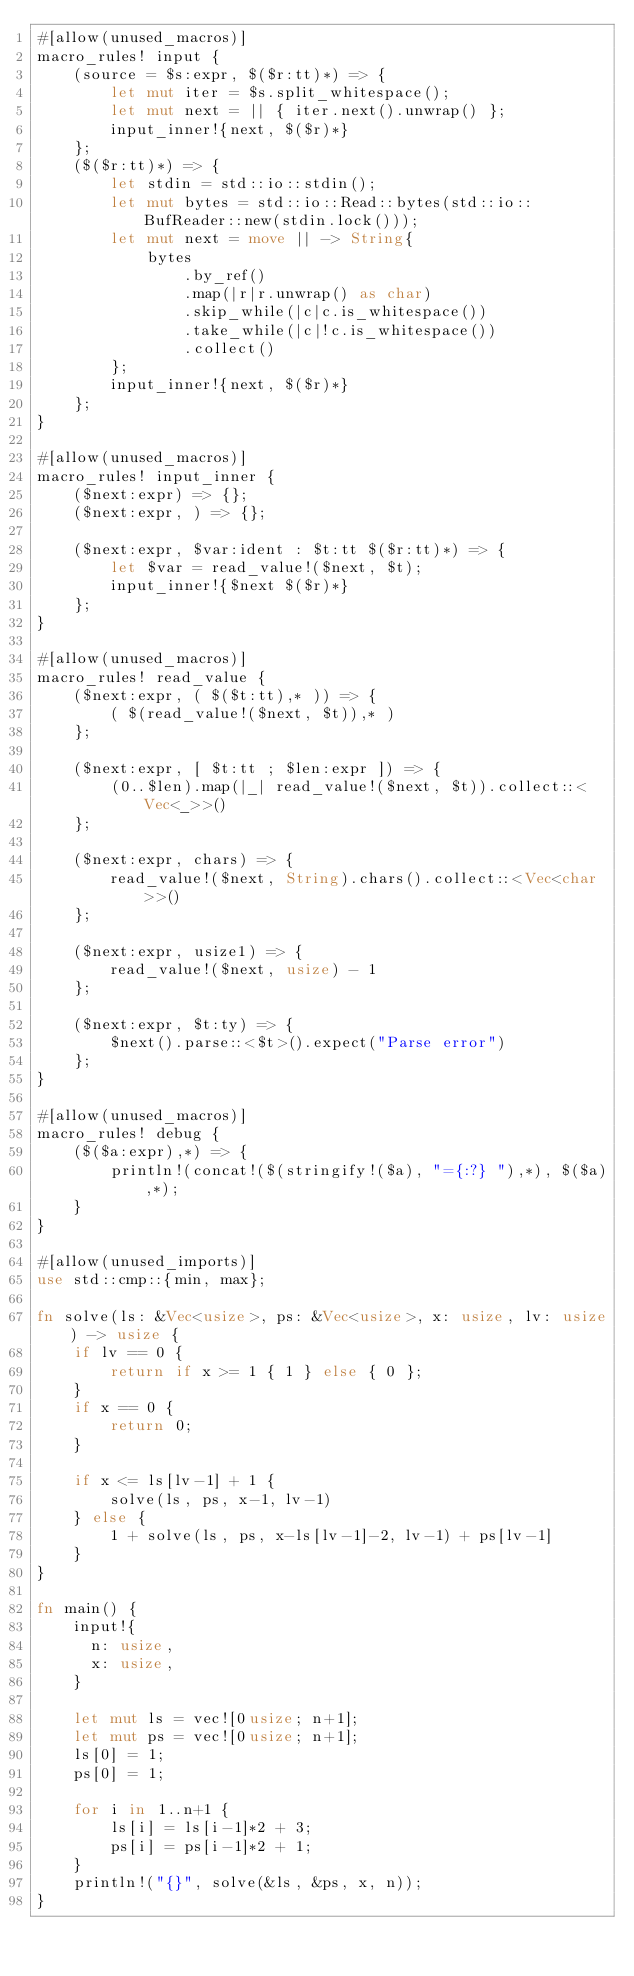Convert code to text. <code><loc_0><loc_0><loc_500><loc_500><_Rust_>#[allow(unused_macros)]
macro_rules! input {
    (source = $s:expr, $($r:tt)*) => {
        let mut iter = $s.split_whitespace();
        let mut next = || { iter.next().unwrap() };
        input_inner!{next, $($r)*}
    };
    ($($r:tt)*) => {
        let stdin = std::io::stdin();
        let mut bytes = std::io::Read::bytes(std::io::BufReader::new(stdin.lock()));
        let mut next = move || -> String{
            bytes
                .by_ref()
                .map(|r|r.unwrap() as char)
                .skip_while(|c|c.is_whitespace())
                .take_while(|c|!c.is_whitespace())
                .collect()
        };
        input_inner!{next, $($r)*}
    };
}

#[allow(unused_macros)]
macro_rules! input_inner {
    ($next:expr) => {};
    ($next:expr, ) => {};

    ($next:expr, $var:ident : $t:tt $($r:tt)*) => {
        let $var = read_value!($next, $t);
        input_inner!{$next $($r)*}
    };
}

#[allow(unused_macros)]
macro_rules! read_value {
    ($next:expr, ( $($t:tt),* )) => {
        ( $(read_value!($next, $t)),* )
    };

    ($next:expr, [ $t:tt ; $len:expr ]) => {
        (0..$len).map(|_| read_value!($next, $t)).collect::<Vec<_>>()
    };

    ($next:expr, chars) => {
        read_value!($next, String).chars().collect::<Vec<char>>()
    };

    ($next:expr, usize1) => {
        read_value!($next, usize) - 1
    };

    ($next:expr, $t:ty) => {
        $next().parse::<$t>().expect("Parse error")
    };
}

#[allow(unused_macros)]
macro_rules! debug {
    ($($a:expr),*) => {
        println!(concat!($(stringify!($a), "={:?} "),*), $($a),*);
    }
}

#[allow(unused_imports)]
use std::cmp::{min, max};

fn solve(ls: &Vec<usize>, ps: &Vec<usize>, x: usize, lv: usize) -> usize {
    if lv == 0 {
        return if x >= 1 { 1 } else { 0 };
    }
    if x == 0 {
        return 0;
    }

    if x <= ls[lv-1] + 1 {
        solve(ls, ps, x-1, lv-1)
    } else {
        1 + solve(ls, ps, x-ls[lv-1]-2, lv-1) + ps[lv-1]
    }
}

fn main() {
    input!{
      n: usize,
      x: usize,
    }

    let mut ls = vec![0usize; n+1];
    let mut ps = vec![0usize; n+1];
    ls[0] = 1;
    ps[0] = 1;

    for i in 1..n+1 {
        ls[i] = ls[i-1]*2 + 3;
        ps[i] = ps[i-1]*2 + 1;
    }
    println!("{}", solve(&ls, &ps, x, n));
}
</code> 